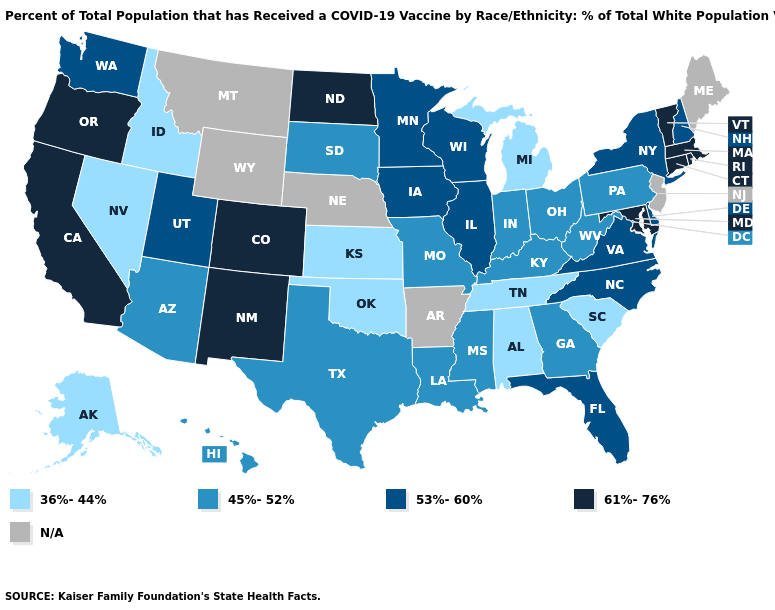Is the legend a continuous bar?
Quick response, please. No. What is the highest value in states that border Alabama?
Keep it brief. 53%-60%. Which states have the highest value in the USA?
Be succinct. California, Colorado, Connecticut, Maryland, Massachusetts, New Mexico, North Dakota, Oregon, Rhode Island, Vermont. Which states have the lowest value in the Northeast?
Write a very short answer. Pennsylvania. Does the first symbol in the legend represent the smallest category?
Quick response, please. Yes. Among the states that border Connecticut , does New York have the lowest value?
Concise answer only. Yes. What is the value of South Dakota?
Answer briefly. 45%-52%. Name the states that have a value in the range 36%-44%?
Write a very short answer. Alabama, Alaska, Idaho, Kansas, Michigan, Nevada, Oklahoma, South Carolina, Tennessee. What is the highest value in states that border South Dakota?
Keep it brief. 61%-76%. Which states have the lowest value in the South?
Write a very short answer. Alabama, Oklahoma, South Carolina, Tennessee. What is the lowest value in states that border West Virginia?
Answer briefly. 45%-52%. Which states have the lowest value in the USA?
Concise answer only. Alabama, Alaska, Idaho, Kansas, Michigan, Nevada, Oklahoma, South Carolina, Tennessee. What is the lowest value in the USA?
Short answer required. 36%-44%. 